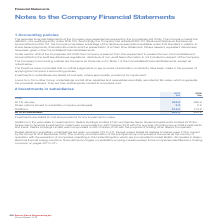According to Spirax Sarco Engineering Plc's financial document, What is the country of incorporation of the principal Group companies? the same as the country of operation with the exception of companies operating in the United Kingdom which are incorporated in Great Britain. The document states: "incorporation of the principal Group companies is the same as the country of operation with the exception of companies operating in the United Kingdom..." Also, What is the cost of investment at the end of 2019? According to the financial document, 662.0 (in millions). The relevant text states: "es 2.2 2.6 Additions 214.0 173.8 At 31st December 662.0 445.8..." Also, What made up the Additions in the year of 2019? The document shows two values: investments in Gestra Holdings Limited £1.6m and Spirax Sarco America Investments Limited £212.4m. From the document: "Additions in the year relate to investments in Gestra Holdings Limited £1.6m and Spirax Sarco America Investments Limited £212.4m. Spirax Sarco Americ..." Additionally, In which year was the Share options issued to subsidiary company employees larger? According to the financial document, 2018. The relevant text states: "2018 £m Cost: At 1st January 445.8 269.4 Share options issued to subsidiary company employees 2.2 2.6 Ad..." Also, can you calculate: What was the change in the cost at 31st December in 2019 from 2018? Based on the calculation: 662.0-445.8, the result is 216.2 (in millions). This is based on the information: "es 2.2 2.6 Additions 214.0 173.8 At 31st December 662.0 445.8 2018 £m Cost: At 1st January 445.8 269.4 Share options issued to subsidiary company employees 2.2 2.6 Additions 214.0 173.8 At 31st De..." The key data points involved are: 445.8, 662.0. Also, can you calculate: What was the percentage change in the cost at 31st December in 2019 from 2018? To answer this question, I need to perform calculations using the financial data. The calculation is: (662.0-445.8)/445.8, which equals 48.5 (percentage). This is based on the information: "es 2.2 2.6 Additions 214.0 173.8 At 31st December 662.0 445.8 2018 £m Cost: At 1st January 445.8 269.4 Share options issued to subsidiary company employees 2.2 2.6 Additions 214.0 173.8 At 31st De..." The key data points involved are: 445.8, 662.0. 